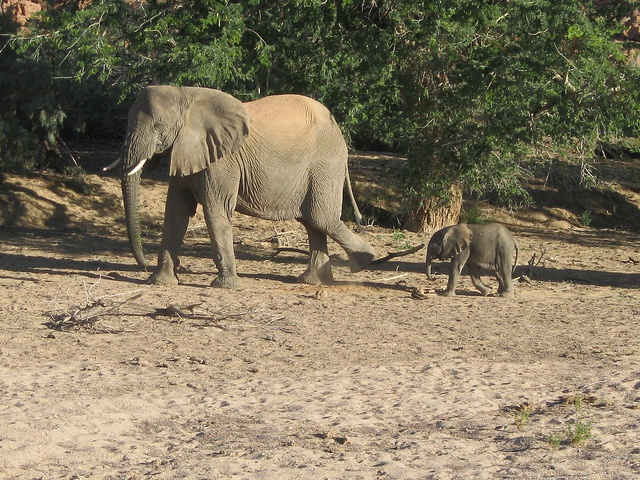Describe the objects in this image and their specific colors. I can see elephant in gray, tan, and black tones and elephant in gray, tan, and black tones in this image. 